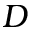Convert formula to latex. <formula><loc_0><loc_0><loc_500><loc_500>D</formula> 